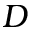Convert formula to latex. <formula><loc_0><loc_0><loc_500><loc_500>D</formula> 